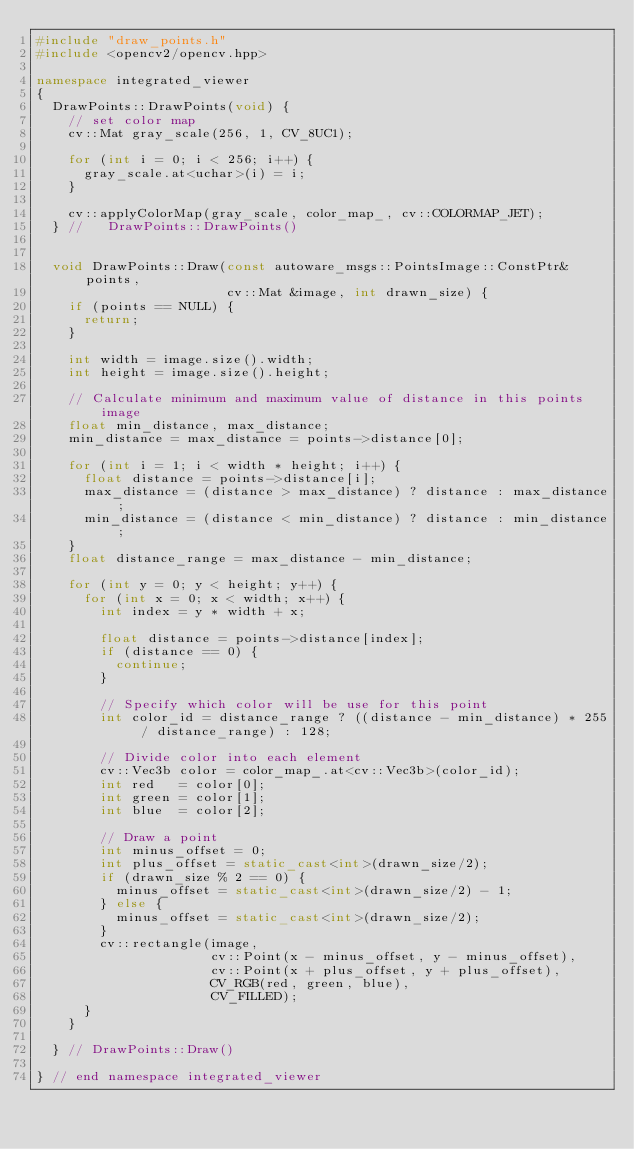<code> <loc_0><loc_0><loc_500><loc_500><_C++_>#include "draw_points.h"
#include <opencv2/opencv.hpp>

namespace integrated_viewer
{
  DrawPoints::DrawPoints(void) {
    // set color map
    cv::Mat gray_scale(256, 1, CV_8UC1);

    for (int i = 0; i < 256; i++) {
      gray_scale.at<uchar>(i) = i;
    }

    cv::applyColorMap(gray_scale, color_map_, cv::COLORMAP_JET);
  } //   DrawPoints::DrawPoints()


  void DrawPoints::Draw(const autoware_msgs::PointsImage::ConstPtr& points,
                        cv::Mat &image, int drawn_size) {
    if (points == NULL) {
      return;
    }

    int width = image.size().width;
    int height = image.size().height;

    // Calculate minimum and maximum value of distance in this points image
    float min_distance, max_distance;
    min_distance = max_distance = points->distance[0];

    for (int i = 1; i < width * height; i++) {
      float distance = points->distance[i];
      max_distance = (distance > max_distance) ? distance : max_distance;
      min_distance = (distance < min_distance) ? distance : min_distance;
    }
    float distance_range = max_distance - min_distance;

    for (int y = 0; y < height; y++) {
      for (int x = 0; x < width; x++) {
        int index = y * width + x;

        float distance = points->distance[index];
        if (distance == 0) {
          continue;
        }

        // Specify which color will be use for this point
        int color_id = distance_range ? ((distance - min_distance) * 255 / distance_range) : 128;

        // Divide color into each element
        cv::Vec3b color = color_map_.at<cv::Vec3b>(color_id);
        int red   = color[0];
        int green = color[1];
        int blue  = color[2];

        // Draw a point
        int minus_offset = 0;
        int plus_offset = static_cast<int>(drawn_size/2);
        if (drawn_size % 2 == 0) {
          minus_offset = static_cast<int>(drawn_size/2) - 1;
        } else {
          minus_offset = static_cast<int>(drawn_size/2);
        }
        cv::rectangle(image,
                      cv::Point(x - minus_offset, y - minus_offset),
                      cv::Point(x + plus_offset, y + plus_offset),
                      CV_RGB(red, green, blue),
                      CV_FILLED);
      }
    }

  } // DrawPoints::Draw()

} // end namespace integrated_viewer
</code> 